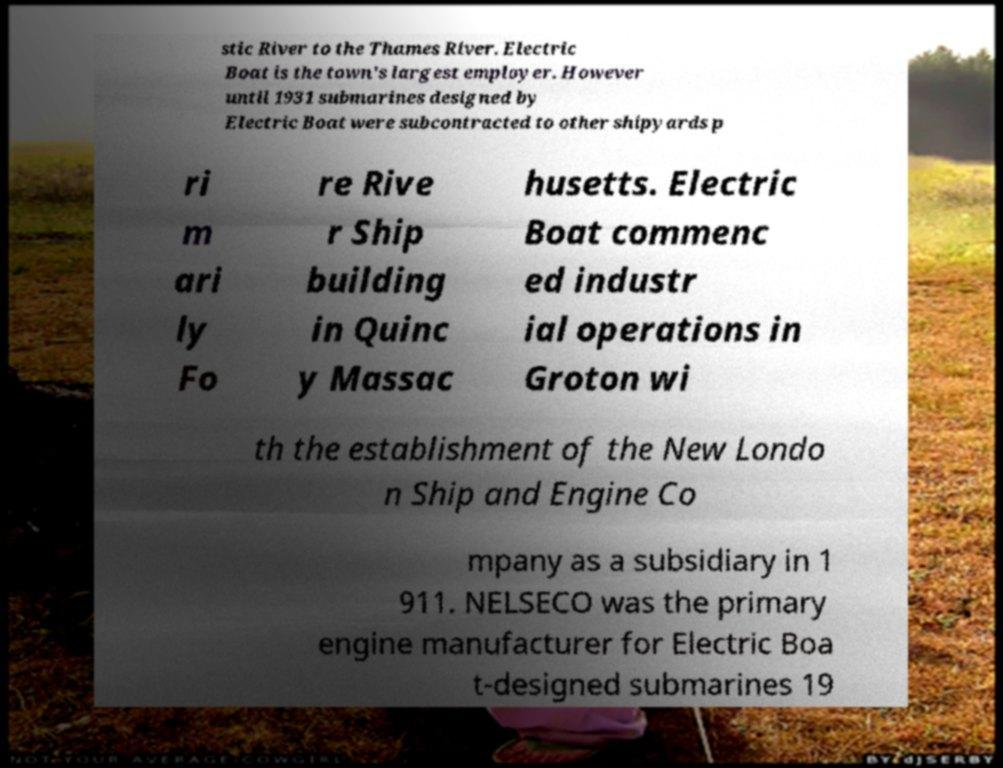For documentation purposes, I need the text within this image transcribed. Could you provide that? stic River to the Thames River. Electric Boat is the town's largest employer. However until 1931 submarines designed by Electric Boat were subcontracted to other shipyards p ri m ari ly Fo re Rive r Ship building in Quinc y Massac husetts. Electric Boat commenc ed industr ial operations in Groton wi th the establishment of the New Londo n Ship and Engine Co mpany as a subsidiary in 1 911. NELSECO was the primary engine manufacturer for Electric Boa t-designed submarines 19 